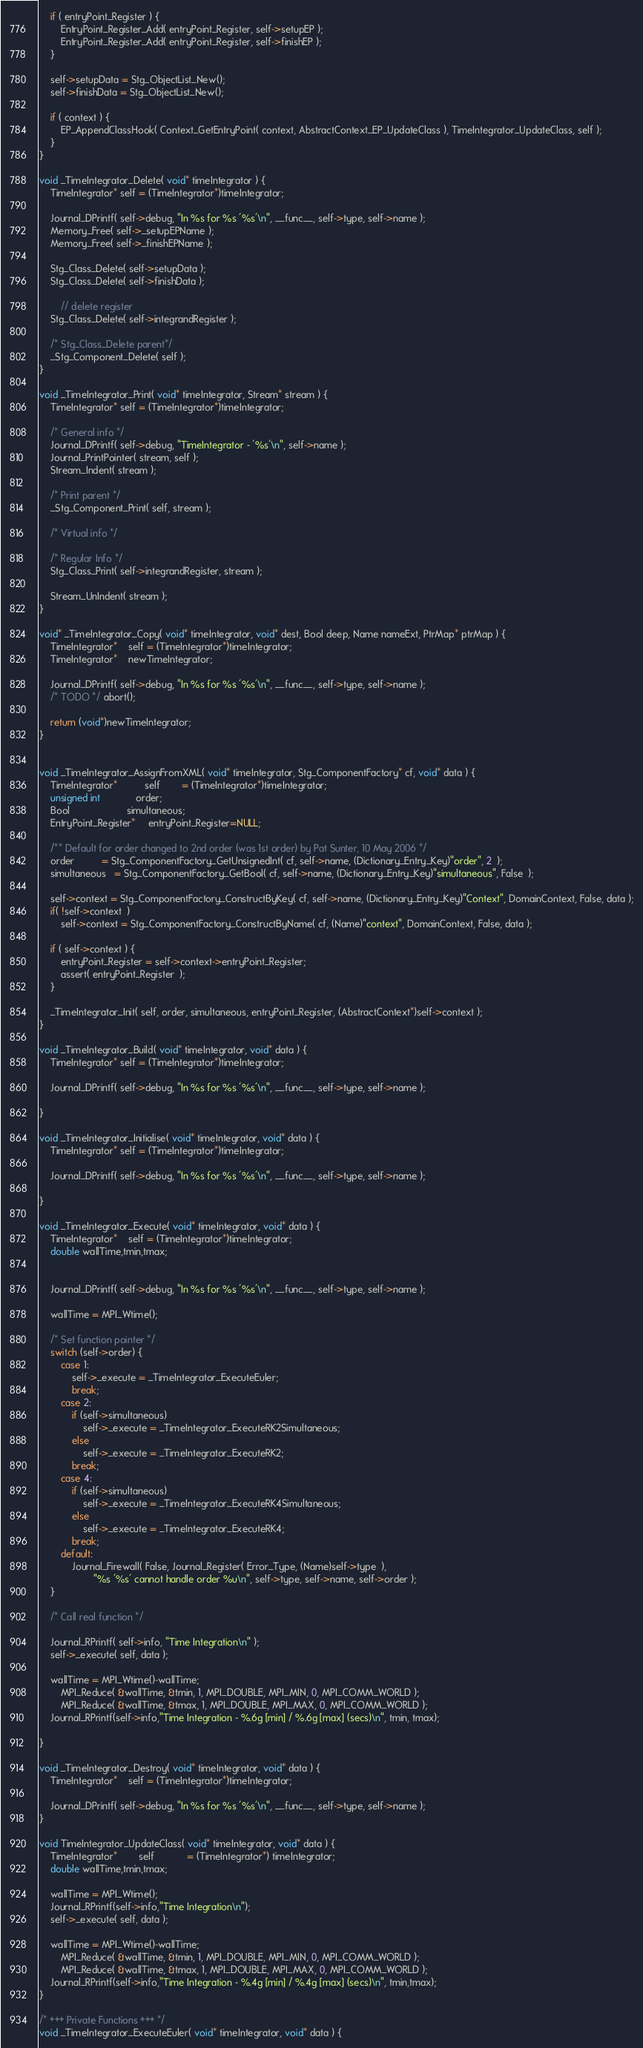Convert code to text. <code><loc_0><loc_0><loc_500><loc_500><_C_>
	if ( entryPoint_Register ) {
		EntryPoint_Register_Add( entryPoint_Register, self->setupEP );
		EntryPoint_Register_Add( entryPoint_Register, self->finishEP );
	}

	self->setupData = Stg_ObjectList_New();
	self->finishData = Stg_ObjectList_New();

	if ( context ) {
		EP_AppendClassHook( Context_GetEntryPoint( context, AbstractContext_EP_UpdateClass ), TimeIntegrator_UpdateClass, self );
	}
}

void _TimeIntegrator_Delete( void* timeIntegrator ) {
	TimeIntegrator* self = (TimeIntegrator*)timeIntegrator;
	
	Journal_DPrintf( self->debug, "In %s for %s '%s'\n", __func__, self->type, self->name );
	Memory_Free( self->_setupEPName );
	Memory_Free( self->_finishEPName );
	
	Stg_Class_Delete( self->setupData );
	Stg_Class_Delete( self->finishData );

        // delete register
	Stg_Class_Delete( self->integrandRegister );
	
	/* Stg_Class_Delete parent*/
	_Stg_Component_Delete( self );
}

void _TimeIntegrator_Print( void* timeIntegrator, Stream* stream ) {
	TimeIntegrator* self = (TimeIntegrator*)timeIntegrator;

	/* General info */
	Journal_DPrintf( self->debug, "TimeIntegrator - '%s'\n", self->name );
	Journal_PrintPointer( stream, self );
	Stream_Indent( stream );
	
	/* Print parent */
	_Stg_Component_Print( self, stream );
	
	/* Virtual info */

	/* Regular Info */
	Stg_Class_Print( self->integrandRegister, stream );
	
	Stream_UnIndent( stream );
}

void* _TimeIntegrator_Copy( void* timeIntegrator, void* dest, Bool deep, Name nameExt, PtrMap* ptrMap ) {
	TimeIntegrator*	self = (TimeIntegrator*)timeIntegrator;
	TimeIntegrator*	newTimeIntegrator;
	
	Journal_DPrintf( self->debug, "In %s for %s '%s'\n", __func__, self->type, self->name );
	/* TODO */ abort();

	return (void*)newTimeIntegrator;
}


void _TimeIntegrator_AssignFromXML( void* timeIntegrator, Stg_ComponentFactory* cf, void* data ) {
	TimeIntegrator*          self        = (TimeIntegrator*)timeIntegrator;
	unsigned int             order;
	Bool                     simultaneous;
	EntryPoint_Register*     entryPoint_Register=NULL;

	/** Default for order changed to 2nd order (was 1st order) by Pat Sunter, 10 May 2006 */
	order          = Stg_ComponentFactory_GetUnsignedInt( cf, self->name, (Dictionary_Entry_Key)"order", 2  );
	simultaneous   = Stg_ComponentFactory_GetBool( cf, self->name, (Dictionary_Entry_Key)"simultaneous", False  );

	self->context = Stg_ComponentFactory_ConstructByKey( cf, self->name, (Dictionary_Entry_Key)"Context", DomainContext, False, data );
	if( !self->context  )	
		self->context = Stg_ComponentFactory_ConstructByName( cf, (Name)"context", DomainContext, False, data );

    if ( self->context ) {
        entryPoint_Register = self->context->entryPoint_Register;
        assert( entryPoint_Register  );
    }

	_TimeIntegrator_Init( self, order, simultaneous, entryPoint_Register, (AbstractContext*)self->context );
}

void _TimeIntegrator_Build( void* timeIntegrator, void* data ) {
	TimeIntegrator* self = (TimeIntegrator*)timeIntegrator;

	Journal_DPrintf( self->debug, "In %s for %s '%s'\n", __func__, self->type, self->name );

}

void _TimeIntegrator_Initialise( void* timeIntegrator, void* data ) {
	TimeIntegrator* self = (TimeIntegrator*)timeIntegrator;
	
	Journal_DPrintf( self->debug, "In %s for %s '%s'\n", __func__, self->type, self->name );

}

void _TimeIntegrator_Execute( void* timeIntegrator, void* data ) {
	TimeIntegrator*	self = (TimeIntegrator*)timeIntegrator;
	double wallTime,tmin,tmax;


	Journal_DPrintf( self->debug, "In %s for %s '%s'\n", __func__, self->type, self->name );

	wallTime = MPI_Wtime();

	/* Set function pointer */
	switch (self->order) {
		case 1:
			self->_execute = _TimeIntegrator_ExecuteEuler; 
			break;
		case 2:
			if (self->simultaneous) 
				self->_execute = _TimeIntegrator_ExecuteRK2Simultaneous; 
			else
				self->_execute = _TimeIntegrator_ExecuteRK2; 
			break;
		case 4:
			if (self->simultaneous) 
				self->_execute = _TimeIntegrator_ExecuteRK4Simultaneous; 
			else
				self->_execute = _TimeIntegrator_ExecuteRK4; 
			break;
		default:
			Journal_Firewall( False, Journal_Register( Error_Type, (Name)self->type  ),
					"%s '%s' cannot handle order %u\n", self->type, self->name, self->order );
	}

	/* Call real function */
	
	Journal_RPrintf( self->info, "Time Integration\n" );
	self->_execute( self, data );

	wallTime = MPI_Wtime()-wallTime;
        MPI_Reduce( &wallTime, &tmin, 1, MPI_DOUBLE, MPI_MIN, 0, MPI_COMM_WORLD );
        MPI_Reduce( &wallTime, &tmax, 1, MPI_DOUBLE, MPI_MAX, 0, MPI_COMM_WORLD );
	Journal_RPrintf(self->info,"Time Integration - %.6g [min] / %.6g [max] (secs)\n", tmin, tmax);
	
}

void _TimeIntegrator_Destroy( void* timeIntegrator, void* data ) {
	TimeIntegrator*	self = (TimeIntegrator*)timeIntegrator;

	Journal_DPrintf( self->debug, "In %s for %s '%s'\n", __func__, self->type, self->name );
}

void TimeIntegrator_UpdateClass( void* timeIntegrator, void* data ) {
	TimeIntegrator*        self            = (TimeIntegrator*) timeIntegrator;
	double wallTime,tmin,tmax;
	
	wallTime = MPI_Wtime();
	Journal_RPrintf(self->info,"Time Integration\n");
	self->_execute( self, data );

	wallTime = MPI_Wtime()-wallTime;
        MPI_Reduce( &wallTime, &tmin, 1, MPI_DOUBLE, MPI_MIN, 0, MPI_COMM_WORLD );
        MPI_Reduce( &wallTime, &tmax, 1, MPI_DOUBLE, MPI_MAX, 0, MPI_COMM_WORLD );
	Journal_RPrintf(self->info,"Time Integration - %.4g [min] / %.4g [max] (secs)\n", tmin,tmax);	
}

/* +++ Private Functions +++ */
void _TimeIntegrator_ExecuteEuler( void* timeIntegrator, void* data ) {</code> 